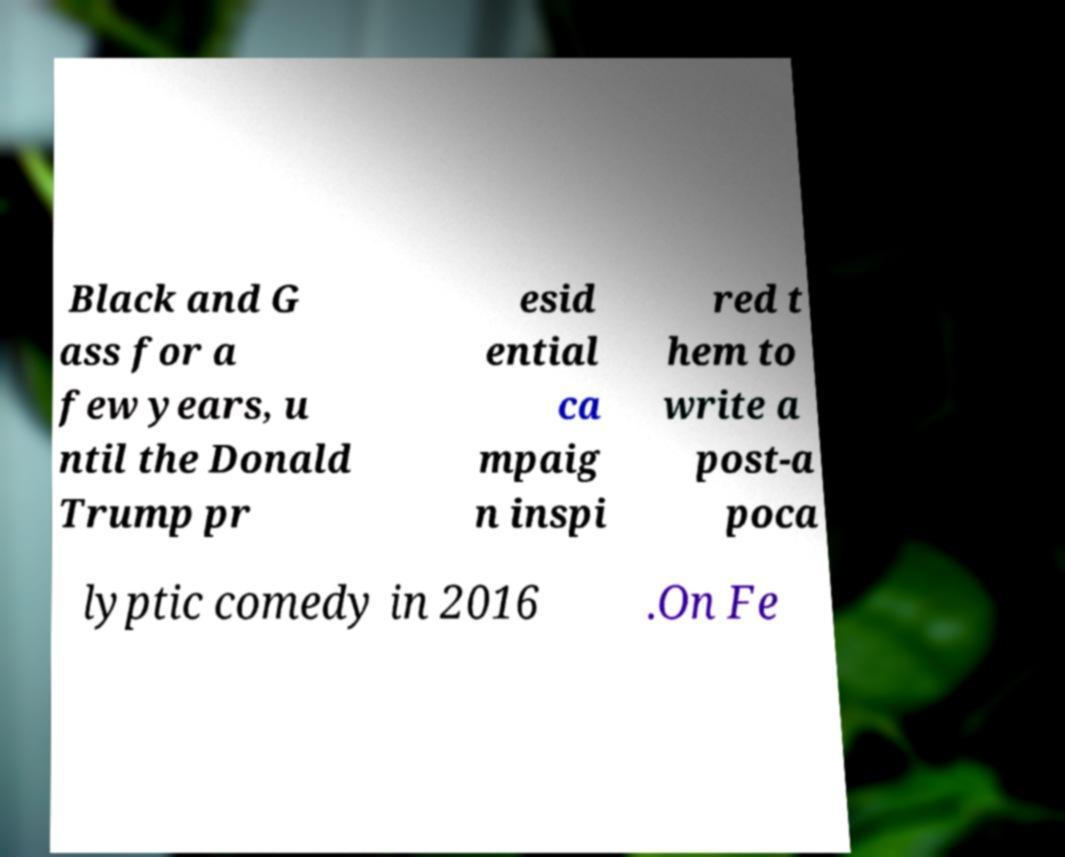Please read and relay the text visible in this image. What does it say? Black and G ass for a few years, u ntil the Donald Trump pr esid ential ca mpaig n inspi red t hem to write a post-a poca lyptic comedy in 2016 .On Fe 